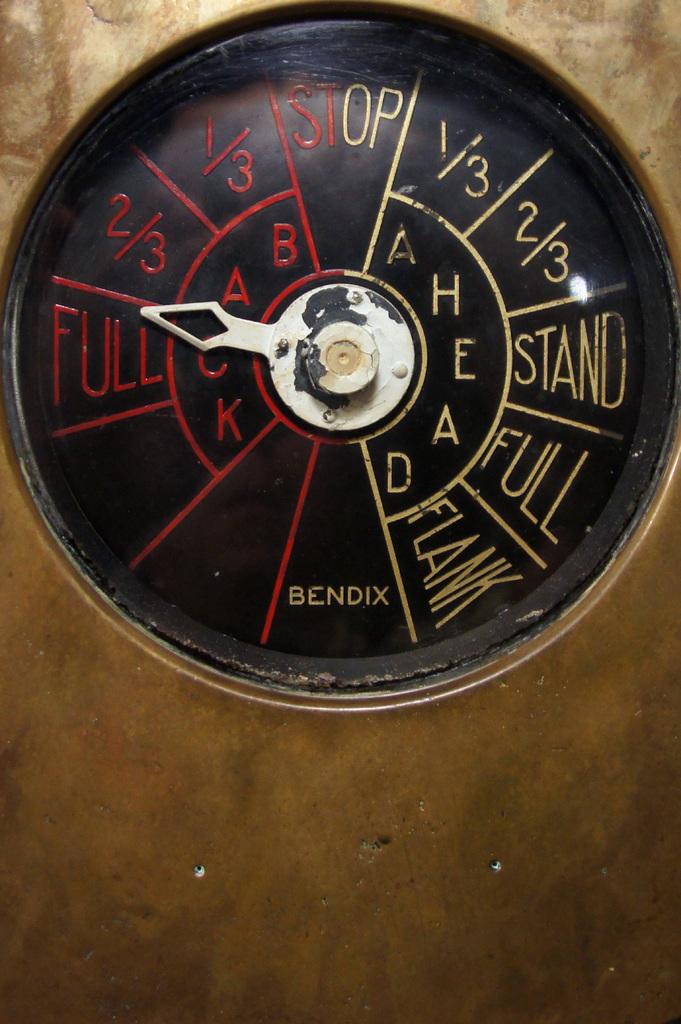The gauge on this meter reads what?
Provide a short and direct response. Full. Whos brand name is on the bottom of the gauge?
Make the answer very short. Bendix. 